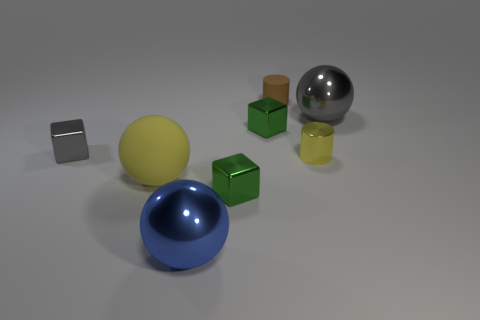Add 1 cubes. How many objects exist? 9 Subtract all cubes. How many objects are left? 5 Add 7 brown matte cylinders. How many brown matte cylinders are left? 8 Add 1 tiny green metallic blocks. How many tiny green metallic blocks exist? 3 Subtract 0 blue cylinders. How many objects are left? 8 Subtract all large yellow spheres. Subtract all small green metal things. How many objects are left? 5 